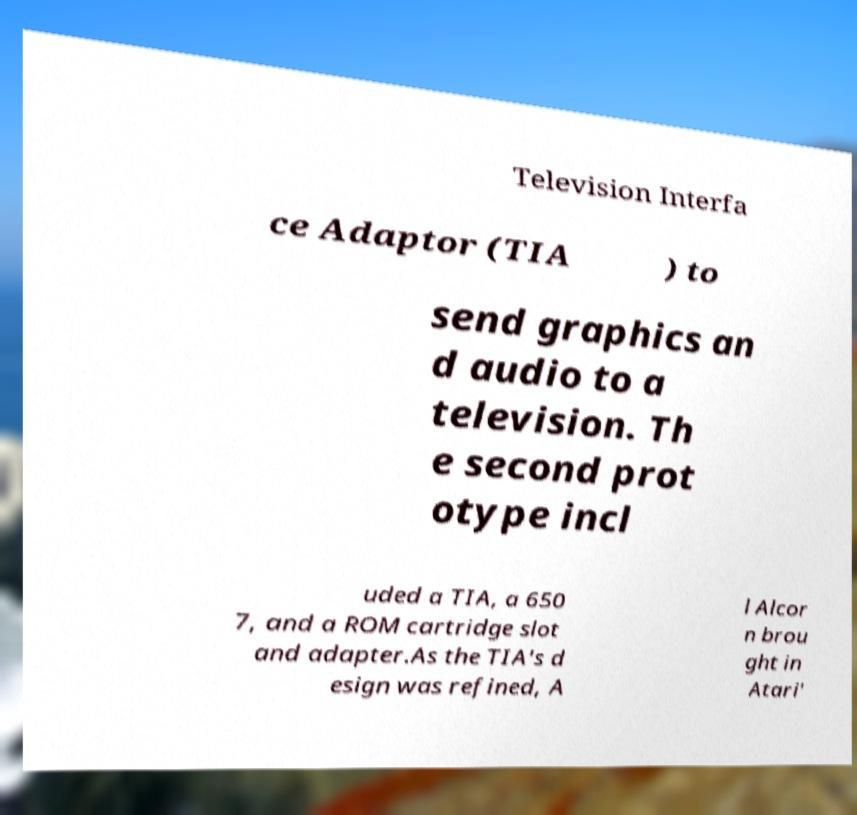Can you accurately transcribe the text from the provided image for me? Television Interfa ce Adaptor (TIA ) to send graphics an d audio to a television. Th e second prot otype incl uded a TIA, a 650 7, and a ROM cartridge slot and adapter.As the TIA's d esign was refined, A l Alcor n brou ght in Atari' 